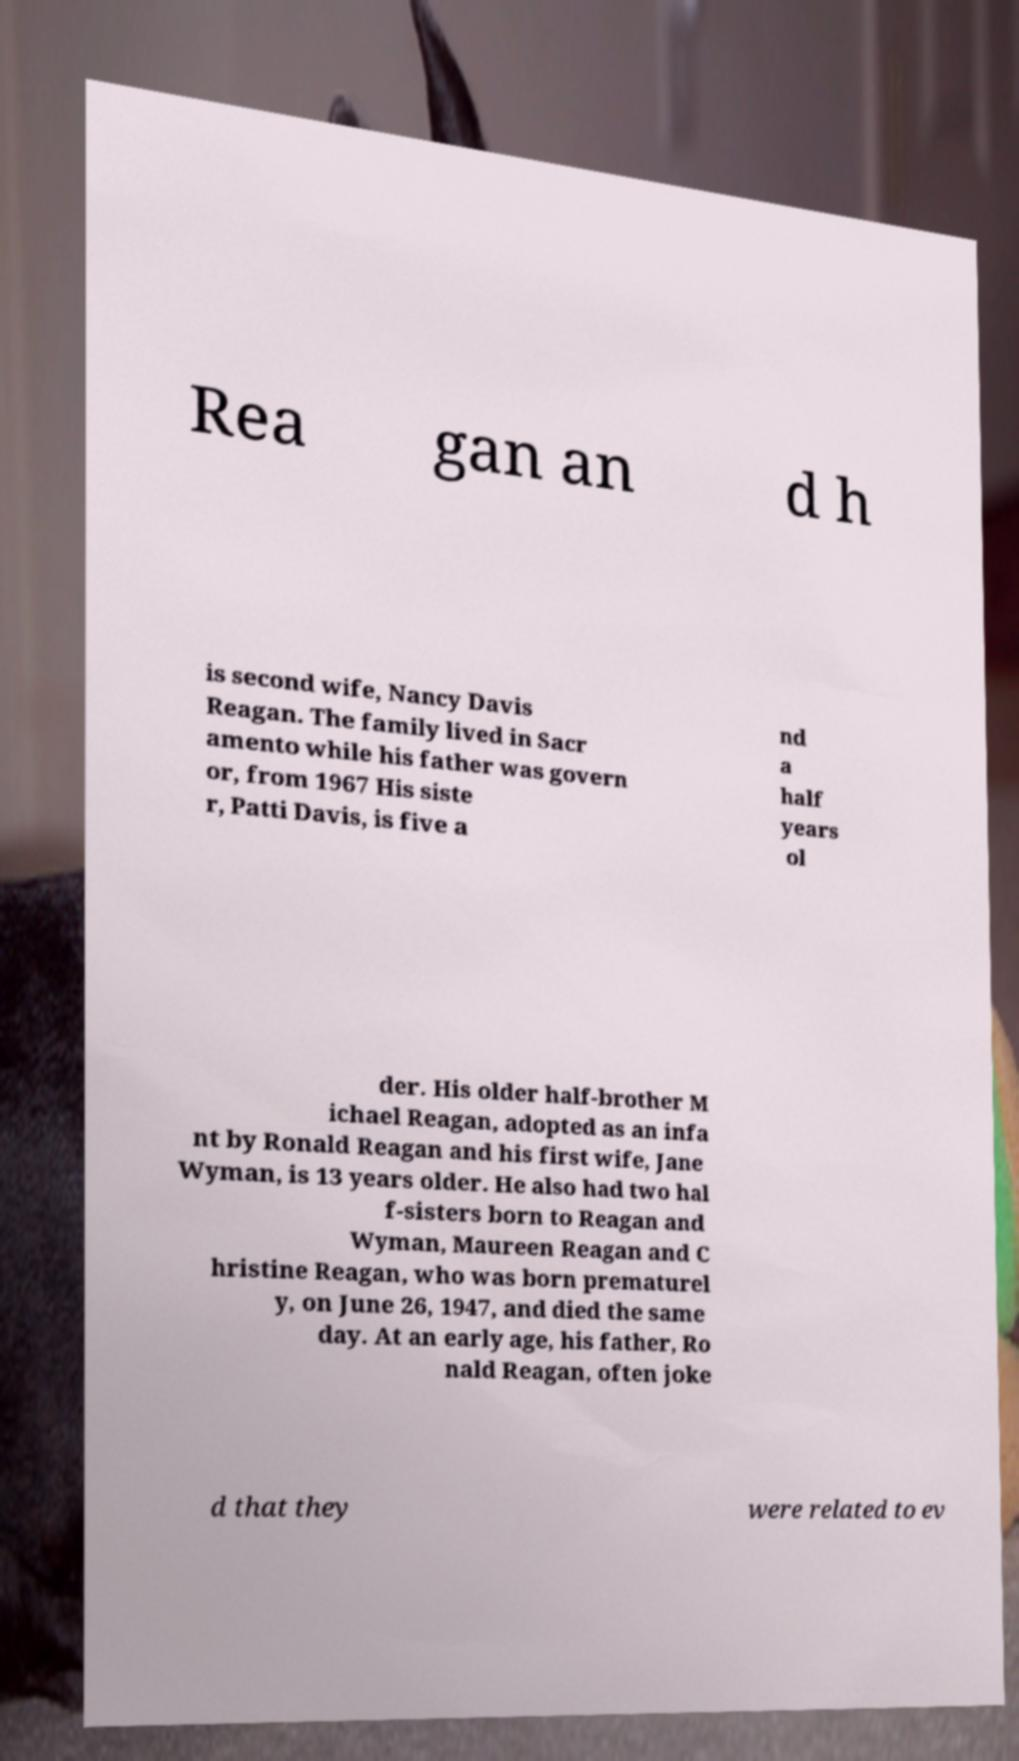Can you accurately transcribe the text from the provided image for me? Rea gan an d h is second wife, Nancy Davis Reagan. The family lived in Sacr amento while his father was govern or, from 1967 His siste r, Patti Davis, is five a nd a half years ol der. His older half-brother M ichael Reagan, adopted as an infa nt by Ronald Reagan and his first wife, Jane Wyman, is 13 years older. He also had two hal f-sisters born to Reagan and Wyman, Maureen Reagan and C hristine Reagan, who was born prematurel y, on June 26, 1947, and died the same day. At an early age, his father, Ro nald Reagan, often joke d that they were related to ev 